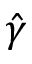<formula> <loc_0><loc_0><loc_500><loc_500>\hat { \gamma }</formula> 